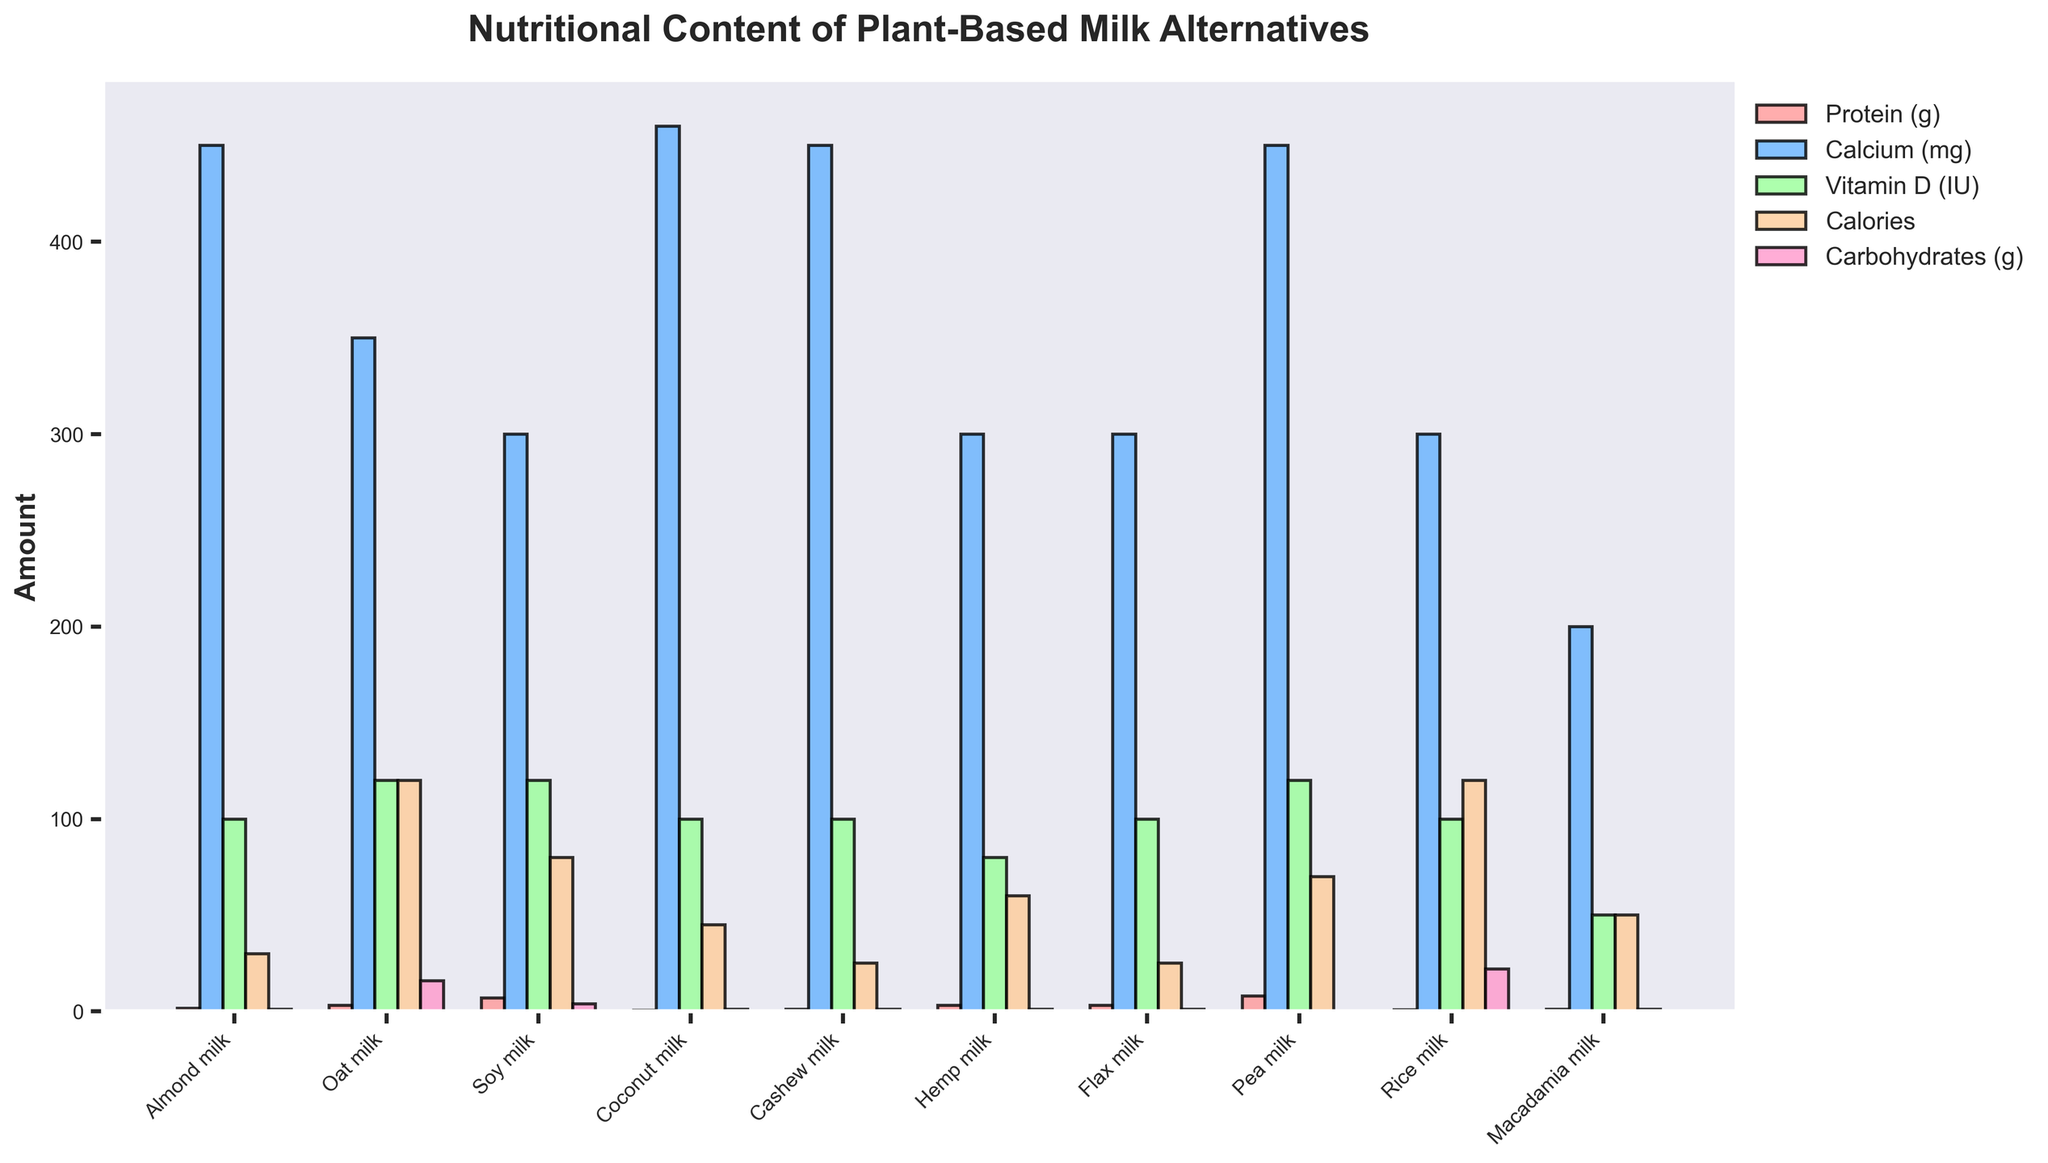Which milk alternative has the highest protein content? By observing the height of the bars in the "Protein (g)" category, we can see that Pea milk has the tallest bar.
Answer: Pea milk Which milk has the lowest calorie count? Looking at the height of the bars in the "Calories" category, the bar for Cashew milk is the shortest.
Answer: Cashew milk How much more protein does Soy milk have compared to Almond milk? The height of the "Protein (g)" bars shows that Soy milk has 7g and Almond milk has 1.5g. The difference is 7g - 1.5g.
Answer: 5.5g Which plant-based milk is highest in Calcium (mg)? Observing the "Calcium (mg)" bars, the tallest bar corresponds to Almond milk and Cashew milk, both showing equivalent calcium content.
Answer: Almond milk and Cashew milk Is the carbohydrate content in Rice milk greater than in Oat milk? Checking the "Carbohydrates (g)" bars for both types, we see that Rice milk has a taller bar (22g) than Oat milk (16g).
Answer: Yes Among Flax milk, Hemp milk, and Macadamia milk, which has the lowest Vitamin D content? Comparing the "Vitamin D (IU)" bars for Flax milk, Hemp milk, and Macadamia milk, Macadamia milk has the shortest bar (50 IU).
Answer: Macadamia milk Which milk alternative has the highest combined total of Vitamin D and Protein content? Summing the "Vitamin D (IU)" and "Protein (g)" bars values for each milk: Pea milk has 8g Protein + 120 IU Vitamin D = 128. This is the highest sum compared to others.
Answer: Pea milk Compare the caloric content of Oat milk and Coconut milk. Which one is higher? Observing the "Calories" bars, Oat milk has a taller bar (120 calories) than Coconut milk (45 calories).
Answer: Oat milk What is the difference in Calcium content between the milk with the most and the milk with the least Calcium? Tallest "Calcium (mg)" bar = Cashew milk and Almond milk both at 450mg. Shortest = Macadamia milk at 200mg. Difference = 450mg - 200mg.
Answer: 250mg Which milk alternative has a carbohydrate content equal to 1g? Looking at the "Carbohydrates (g)" bars, Almond milk, Coconut milk, Cashew milk, Hemp milk, Flax milk, and Macadamia milk all have equivalent short bars, indicating 1g.
Answer: Almond, Coconut, Cashew, Hemp, Flax, and Macadamia milk 